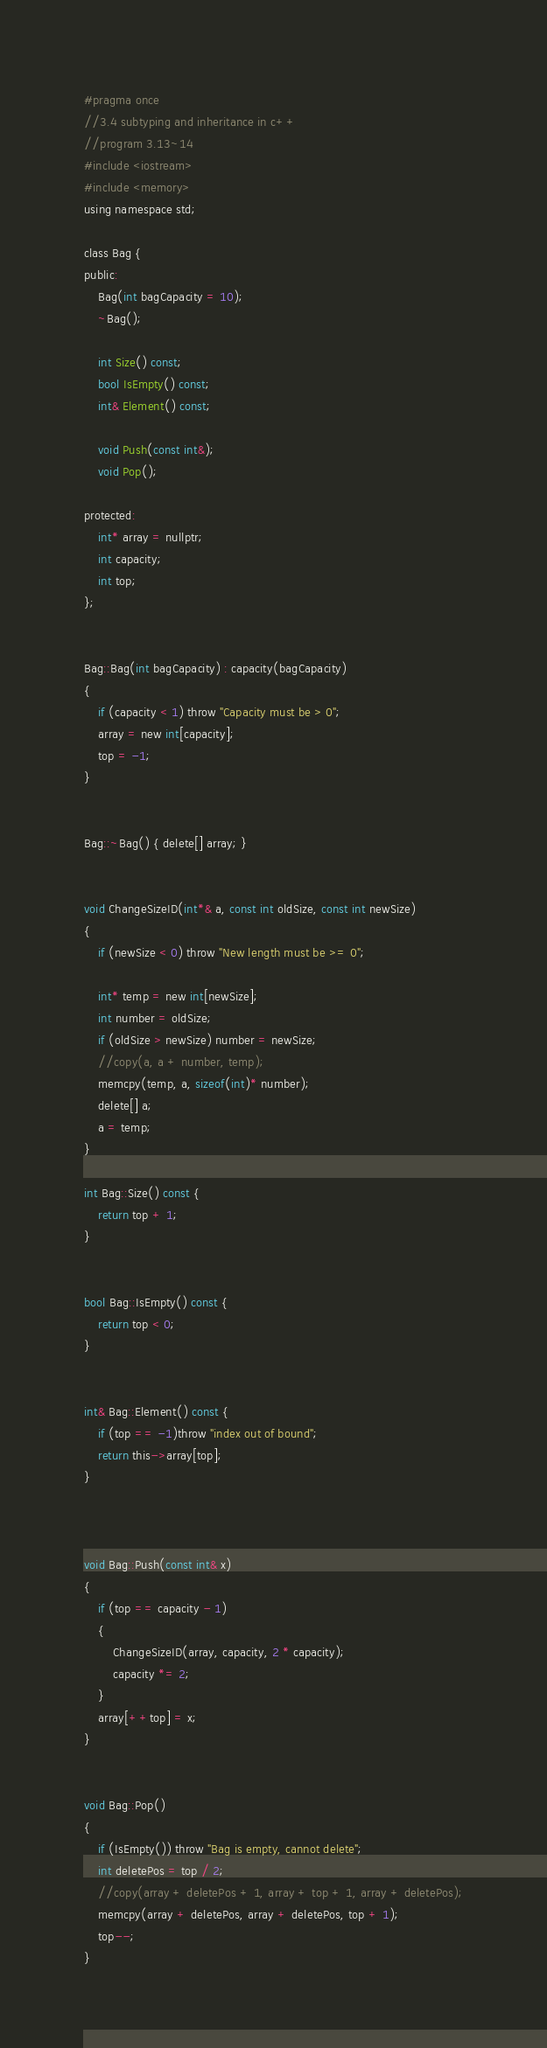Convert code to text. <code><loc_0><loc_0><loc_500><loc_500><_C_>#pragma once
//3.4 subtyping and inheritance in c++
//program 3.13~14
#include <iostream>
#include <memory>
using namespace std;

class Bag {
public:
	Bag(int bagCapacity = 10);
	~Bag();

	int Size() const;
	bool IsEmpty() const;
	int& Element() const;

	void Push(const int&);
	void Pop();

protected:
	int* array = nullptr;
	int capacity;
	int top;
};


Bag::Bag(int bagCapacity) : capacity(bagCapacity)
{
	if (capacity < 1) throw "Capacity must be > 0";
	array = new int[capacity];
	top = -1;
}


Bag::~Bag() { delete[] array; }


void ChangeSizeID(int*& a, const int oldSize, const int newSize)
{
	if (newSize < 0) throw "New length must be >= 0";

	int* temp = new int[newSize];
	int number = oldSize;
	if (oldSize > newSize) number = newSize;
	//copy(a, a + number, temp);
	memcpy(temp, a, sizeof(int)* number);
	delete[] a;
	a = temp;
}

int Bag::Size() const {
	return top + 1;
}


bool Bag::IsEmpty() const {
	return top < 0;
}


int& Bag::Element() const {
	if (top == -1)throw "index out of bound";
	return this->array[top];
}



void Bag::Push(const int& x)
{
	if (top == capacity - 1)
	{
		ChangeSizeID(array, capacity, 2 * capacity);
		capacity *= 2;
	}
	array[++top] = x;
}


void Bag::Pop()
{
	if (IsEmpty()) throw "Bag is empty, cannot delete";
	int deletePos = top / 2;
	//copy(array + deletePos + 1, array + top + 1, array + deletePos);
	memcpy(array + deletePos, array + deletePos, top + 1);
	top--;
}
</code> 